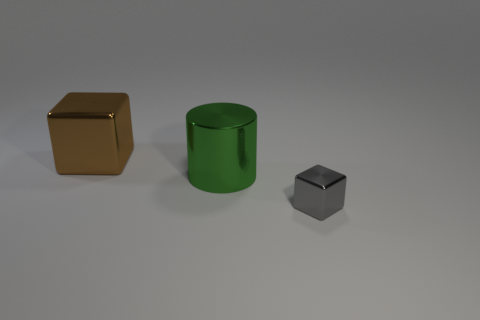Add 3 big brown blocks. How many objects exist? 6 Subtract all cylinders. How many objects are left? 2 Subtract all large brown metallic things. Subtract all brown shiny blocks. How many objects are left? 1 Add 3 small metallic objects. How many small metallic objects are left? 4 Add 1 tiny gray metallic cubes. How many tiny gray metallic cubes exist? 2 Subtract 0 cyan balls. How many objects are left? 3 